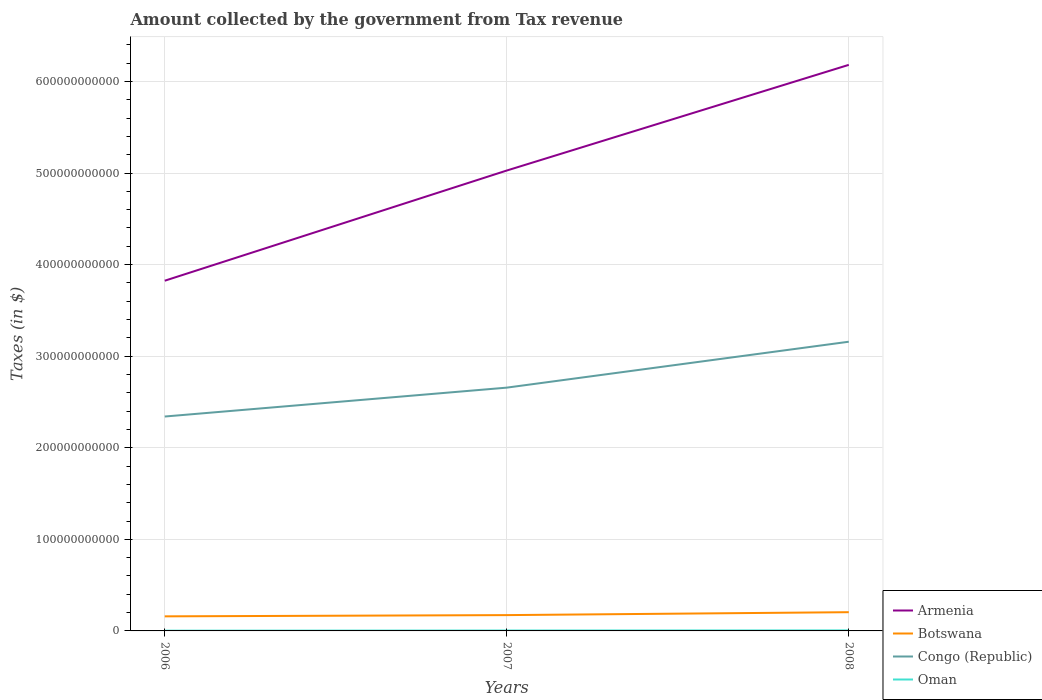Does the line corresponding to Congo (Republic) intersect with the line corresponding to Armenia?
Provide a succinct answer. No. Across all years, what is the maximum amount collected by the government from tax revenue in Botswana?
Keep it short and to the point. 1.59e+1. In which year was the amount collected by the government from tax revenue in Oman maximum?
Make the answer very short. 2006. What is the total amount collected by the government from tax revenue in Botswana in the graph?
Give a very brief answer. -4.54e+09. What is the difference between the highest and the second highest amount collected by the government from tax revenue in Botswana?
Your answer should be very brief. 4.54e+09. How many lines are there?
Provide a short and direct response. 4. What is the difference between two consecutive major ticks on the Y-axis?
Offer a terse response. 1.00e+11. Are the values on the major ticks of Y-axis written in scientific E-notation?
Your answer should be compact. No. Does the graph contain grids?
Make the answer very short. Yes. Where does the legend appear in the graph?
Make the answer very short. Bottom right. How are the legend labels stacked?
Provide a succinct answer. Vertical. What is the title of the graph?
Keep it short and to the point. Amount collected by the government from Tax revenue. Does "Bahamas" appear as one of the legend labels in the graph?
Your answer should be very brief. No. What is the label or title of the X-axis?
Your answer should be very brief. Years. What is the label or title of the Y-axis?
Your answer should be very brief. Taxes (in $). What is the Taxes (in $) in Armenia in 2006?
Offer a terse response. 3.82e+11. What is the Taxes (in $) in Botswana in 2006?
Ensure brevity in your answer.  1.59e+1. What is the Taxes (in $) of Congo (Republic) in 2006?
Keep it short and to the point. 2.34e+11. What is the Taxes (in $) of Oman in 2006?
Your answer should be very brief. 2.78e+08. What is the Taxes (in $) in Armenia in 2007?
Ensure brevity in your answer.  5.03e+11. What is the Taxes (in $) of Botswana in 2007?
Give a very brief answer. 1.73e+1. What is the Taxes (in $) of Congo (Republic) in 2007?
Make the answer very short. 2.66e+11. What is the Taxes (in $) in Oman in 2007?
Make the answer very short. 4.38e+08. What is the Taxes (in $) in Armenia in 2008?
Keep it short and to the point. 6.18e+11. What is the Taxes (in $) in Botswana in 2008?
Ensure brevity in your answer.  2.05e+1. What is the Taxes (in $) in Congo (Republic) in 2008?
Offer a terse response. 3.16e+11. What is the Taxes (in $) in Oman in 2008?
Your answer should be very brief. 5.66e+08. Across all years, what is the maximum Taxes (in $) of Armenia?
Provide a short and direct response. 6.18e+11. Across all years, what is the maximum Taxes (in $) of Botswana?
Give a very brief answer. 2.05e+1. Across all years, what is the maximum Taxes (in $) of Congo (Republic)?
Ensure brevity in your answer.  3.16e+11. Across all years, what is the maximum Taxes (in $) of Oman?
Offer a terse response. 5.66e+08. Across all years, what is the minimum Taxes (in $) in Armenia?
Give a very brief answer. 3.82e+11. Across all years, what is the minimum Taxes (in $) in Botswana?
Ensure brevity in your answer.  1.59e+1. Across all years, what is the minimum Taxes (in $) of Congo (Republic)?
Offer a very short reply. 2.34e+11. Across all years, what is the minimum Taxes (in $) of Oman?
Provide a succinct answer. 2.78e+08. What is the total Taxes (in $) in Armenia in the graph?
Offer a terse response. 1.50e+12. What is the total Taxes (in $) of Botswana in the graph?
Offer a very short reply. 5.36e+1. What is the total Taxes (in $) in Congo (Republic) in the graph?
Offer a terse response. 8.16e+11. What is the total Taxes (in $) in Oman in the graph?
Offer a terse response. 1.28e+09. What is the difference between the Taxes (in $) of Armenia in 2006 and that in 2007?
Keep it short and to the point. -1.20e+11. What is the difference between the Taxes (in $) of Botswana in 2006 and that in 2007?
Provide a short and direct response. -1.35e+09. What is the difference between the Taxes (in $) in Congo (Republic) in 2006 and that in 2007?
Give a very brief answer. -3.15e+1. What is the difference between the Taxes (in $) in Oman in 2006 and that in 2007?
Keep it short and to the point. -1.59e+08. What is the difference between the Taxes (in $) of Armenia in 2006 and that in 2008?
Your answer should be compact. -2.36e+11. What is the difference between the Taxes (in $) of Botswana in 2006 and that in 2008?
Provide a succinct answer. -4.54e+09. What is the difference between the Taxes (in $) in Congo (Republic) in 2006 and that in 2008?
Keep it short and to the point. -8.17e+1. What is the difference between the Taxes (in $) of Oman in 2006 and that in 2008?
Offer a terse response. -2.88e+08. What is the difference between the Taxes (in $) of Armenia in 2007 and that in 2008?
Make the answer very short. -1.15e+11. What is the difference between the Taxes (in $) of Botswana in 2007 and that in 2008?
Your answer should be compact. -3.19e+09. What is the difference between the Taxes (in $) of Congo (Republic) in 2007 and that in 2008?
Your answer should be very brief. -5.01e+1. What is the difference between the Taxes (in $) of Oman in 2007 and that in 2008?
Provide a succinct answer. -1.28e+08. What is the difference between the Taxes (in $) in Armenia in 2006 and the Taxes (in $) in Botswana in 2007?
Provide a short and direct response. 3.65e+11. What is the difference between the Taxes (in $) in Armenia in 2006 and the Taxes (in $) in Congo (Republic) in 2007?
Your response must be concise. 1.17e+11. What is the difference between the Taxes (in $) in Armenia in 2006 and the Taxes (in $) in Oman in 2007?
Offer a very short reply. 3.82e+11. What is the difference between the Taxes (in $) of Botswana in 2006 and the Taxes (in $) of Congo (Republic) in 2007?
Offer a terse response. -2.50e+11. What is the difference between the Taxes (in $) of Botswana in 2006 and the Taxes (in $) of Oman in 2007?
Offer a terse response. 1.55e+1. What is the difference between the Taxes (in $) of Congo (Republic) in 2006 and the Taxes (in $) of Oman in 2007?
Offer a very short reply. 2.34e+11. What is the difference between the Taxes (in $) in Armenia in 2006 and the Taxes (in $) in Botswana in 2008?
Provide a succinct answer. 3.62e+11. What is the difference between the Taxes (in $) of Armenia in 2006 and the Taxes (in $) of Congo (Republic) in 2008?
Your answer should be compact. 6.66e+1. What is the difference between the Taxes (in $) of Armenia in 2006 and the Taxes (in $) of Oman in 2008?
Make the answer very short. 3.82e+11. What is the difference between the Taxes (in $) in Botswana in 2006 and the Taxes (in $) in Congo (Republic) in 2008?
Offer a terse response. -3.00e+11. What is the difference between the Taxes (in $) in Botswana in 2006 and the Taxes (in $) in Oman in 2008?
Offer a very short reply. 1.54e+1. What is the difference between the Taxes (in $) of Congo (Republic) in 2006 and the Taxes (in $) of Oman in 2008?
Provide a succinct answer. 2.34e+11. What is the difference between the Taxes (in $) of Armenia in 2007 and the Taxes (in $) of Botswana in 2008?
Your answer should be very brief. 4.82e+11. What is the difference between the Taxes (in $) of Armenia in 2007 and the Taxes (in $) of Congo (Republic) in 2008?
Provide a succinct answer. 1.87e+11. What is the difference between the Taxes (in $) in Armenia in 2007 and the Taxes (in $) in Oman in 2008?
Your answer should be compact. 5.02e+11. What is the difference between the Taxes (in $) in Botswana in 2007 and the Taxes (in $) in Congo (Republic) in 2008?
Make the answer very short. -2.99e+11. What is the difference between the Taxes (in $) of Botswana in 2007 and the Taxes (in $) of Oman in 2008?
Give a very brief answer. 1.67e+1. What is the difference between the Taxes (in $) of Congo (Republic) in 2007 and the Taxes (in $) of Oman in 2008?
Provide a succinct answer. 2.65e+11. What is the average Taxes (in $) of Armenia per year?
Keep it short and to the point. 5.01e+11. What is the average Taxes (in $) in Botswana per year?
Make the answer very short. 1.79e+1. What is the average Taxes (in $) in Congo (Republic) per year?
Your response must be concise. 2.72e+11. What is the average Taxes (in $) of Oman per year?
Offer a very short reply. 4.27e+08. In the year 2006, what is the difference between the Taxes (in $) in Armenia and Taxes (in $) in Botswana?
Give a very brief answer. 3.66e+11. In the year 2006, what is the difference between the Taxes (in $) of Armenia and Taxes (in $) of Congo (Republic)?
Your answer should be compact. 1.48e+11. In the year 2006, what is the difference between the Taxes (in $) in Armenia and Taxes (in $) in Oman?
Make the answer very short. 3.82e+11. In the year 2006, what is the difference between the Taxes (in $) in Botswana and Taxes (in $) in Congo (Republic)?
Your answer should be very brief. -2.18e+11. In the year 2006, what is the difference between the Taxes (in $) of Botswana and Taxes (in $) of Oman?
Your answer should be very brief. 1.56e+1. In the year 2006, what is the difference between the Taxes (in $) in Congo (Republic) and Taxes (in $) in Oman?
Make the answer very short. 2.34e+11. In the year 2007, what is the difference between the Taxes (in $) in Armenia and Taxes (in $) in Botswana?
Offer a terse response. 4.85e+11. In the year 2007, what is the difference between the Taxes (in $) of Armenia and Taxes (in $) of Congo (Republic)?
Offer a very short reply. 2.37e+11. In the year 2007, what is the difference between the Taxes (in $) in Armenia and Taxes (in $) in Oman?
Provide a short and direct response. 5.02e+11. In the year 2007, what is the difference between the Taxes (in $) of Botswana and Taxes (in $) of Congo (Republic)?
Provide a short and direct response. -2.48e+11. In the year 2007, what is the difference between the Taxes (in $) of Botswana and Taxes (in $) of Oman?
Provide a short and direct response. 1.68e+1. In the year 2007, what is the difference between the Taxes (in $) in Congo (Republic) and Taxes (in $) in Oman?
Give a very brief answer. 2.65e+11. In the year 2008, what is the difference between the Taxes (in $) in Armenia and Taxes (in $) in Botswana?
Your response must be concise. 5.98e+11. In the year 2008, what is the difference between the Taxes (in $) of Armenia and Taxes (in $) of Congo (Republic)?
Provide a succinct answer. 3.02e+11. In the year 2008, what is the difference between the Taxes (in $) of Armenia and Taxes (in $) of Oman?
Ensure brevity in your answer.  6.18e+11. In the year 2008, what is the difference between the Taxes (in $) in Botswana and Taxes (in $) in Congo (Republic)?
Your answer should be very brief. -2.95e+11. In the year 2008, what is the difference between the Taxes (in $) in Botswana and Taxes (in $) in Oman?
Offer a very short reply. 1.99e+1. In the year 2008, what is the difference between the Taxes (in $) in Congo (Republic) and Taxes (in $) in Oman?
Offer a terse response. 3.15e+11. What is the ratio of the Taxes (in $) in Armenia in 2006 to that in 2007?
Ensure brevity in your answer.  0.76. What is the ratio of the Taxes (in $) of Botswana in 2006 to that in 2007?
Your answer should be compact. 0.92. What is the ratio of the Taxes (in $) of Congo (Republic) in 2006 to that in 2007?
Offer a terse response. 0.88. What is the ratio of the Taxes (in $) of Oman in 2006 to that in 2007?
Ensure brevity in your answer.  0.64. What is the ratio of the Taxes (in $) in Armenia in 2006 to that in 2008?
Ensure brevity in your answer.  0.62. What is the ratio of the Taxes (in $) in Botswana in 2006 to that in 2008?
Provide a succinct answer. 0.78. What is the ratio of the Taxes (in $) in Congo (Republic) in 2006 to that in 2008?
Provide a short and direct response. 0.74. What is the ratio of the Taxes (in $) in Oman in 2006 to that in 2008?
Your answer should be compact. 0.49. What is the ratio of the Taxes (in $) in Armenia in 2007 to that in 2008?
Your response must be concise. 0.81. What is the ratio of the Taxes (in $) in Botswana in 2007 to that in 2008?
Offer a terse response. 0.84. What is the ratio of the Taxes (in $) of Congo (Republic) in 2007 to that in 2008?
Make the answer very short. 0.84. What is the ratio of the Taxes (in $) of Oman in 2007 to that in 2008?
Offer a very short reply. 0.77. What is the difference between the highest and the second highest Taxes (in $) in Armenia?
Your answer should be compact. 1.15e+11. What is the difference between the highest and the second highest Taxes (in $) of Botswana?
Offer a very short reply. 3.19e+09. What is the difference between the highest and the second highest Taxes (in $) in Congo (Republic)?
Offer a terse response. 5.01e+1. What is the difference between the highest and the second highest Taxes (in $) of Oman?
Your response must be concise. 1.28e+08. What is the difference between the highest and the lowest Taxes (in $) in Armenia?
Your answer should be compact. 2.36e+11. What is the difference between the highest and the lowest Taxes (in $) of Botswana?
Make the answer very short. 4.54e+09. What is the difference between the highest and the lowest Taxes (in $) of Congo (Republic)?
Make the answer very short. 8.17e+1. What is the difference between the highest and the lowest Taxes (in $) in Oman?
Offer a very short reply. 2.88e+08. 